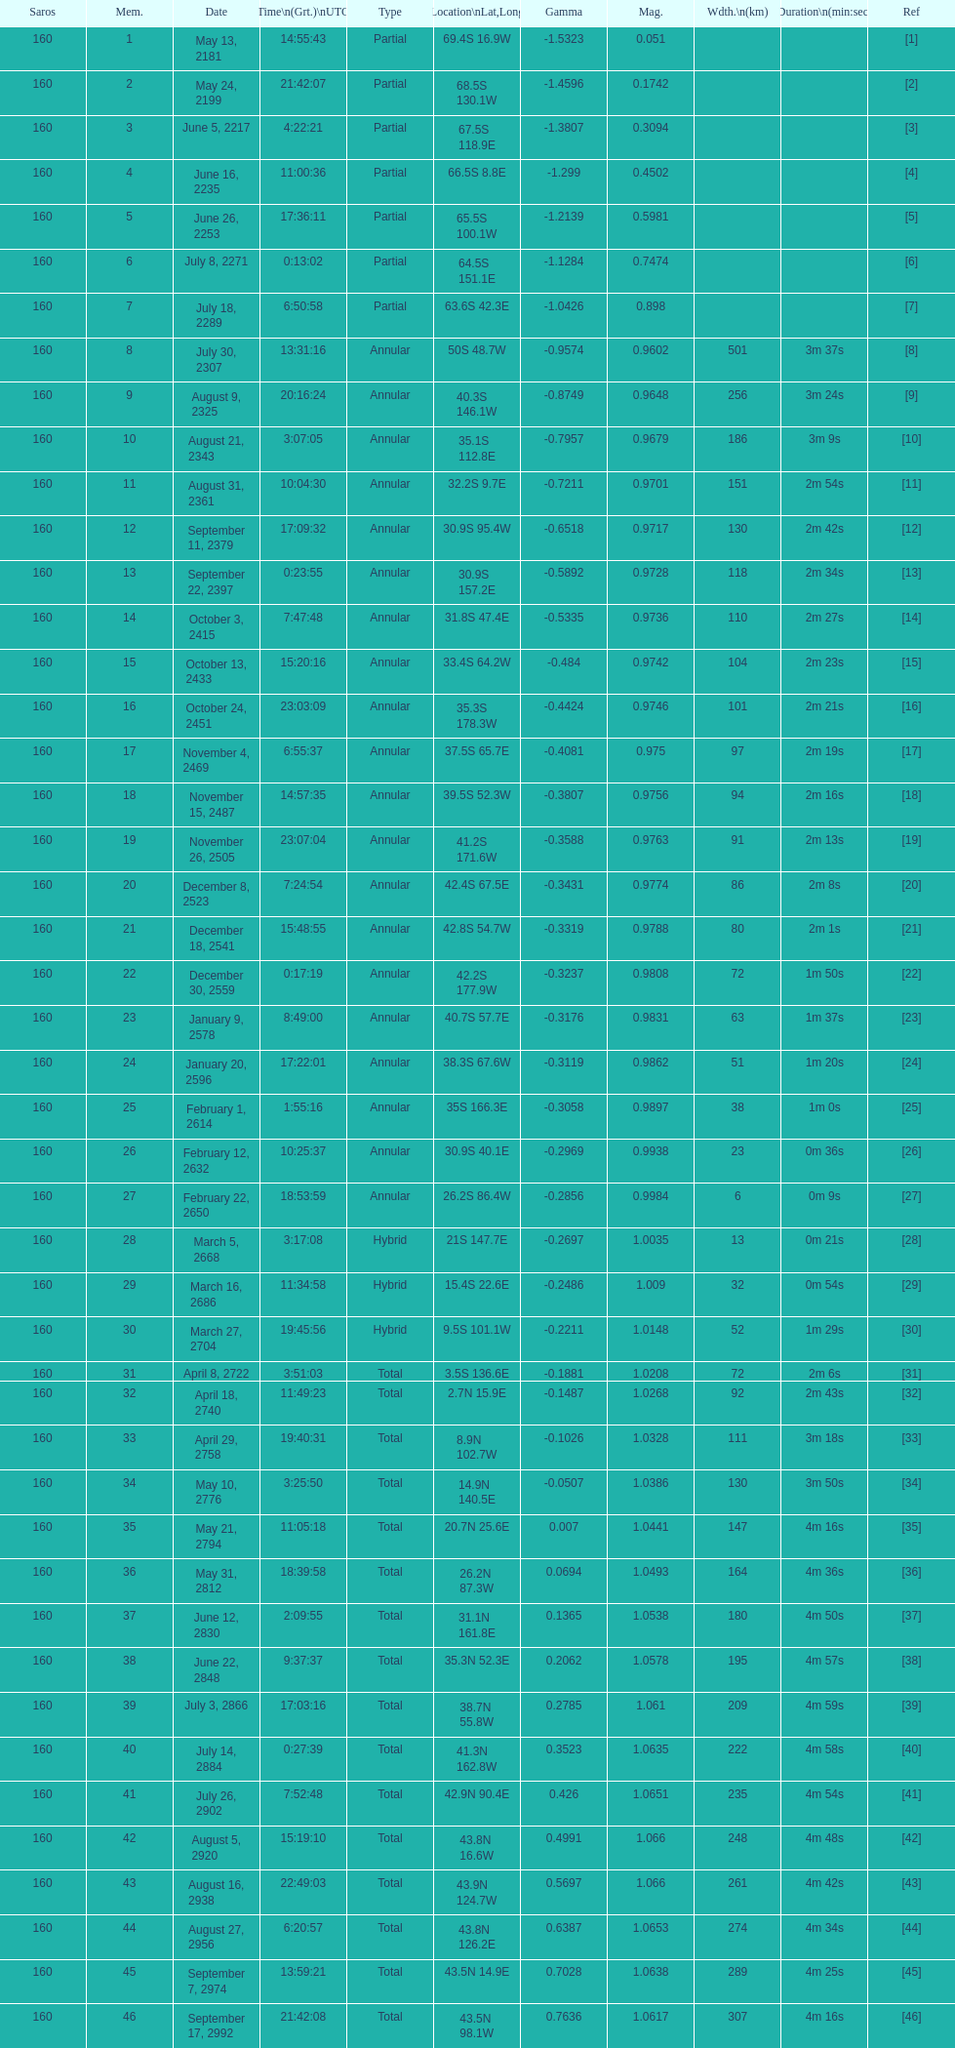What is the previous time for the saros on october 3, 2415? 7:47:48. 